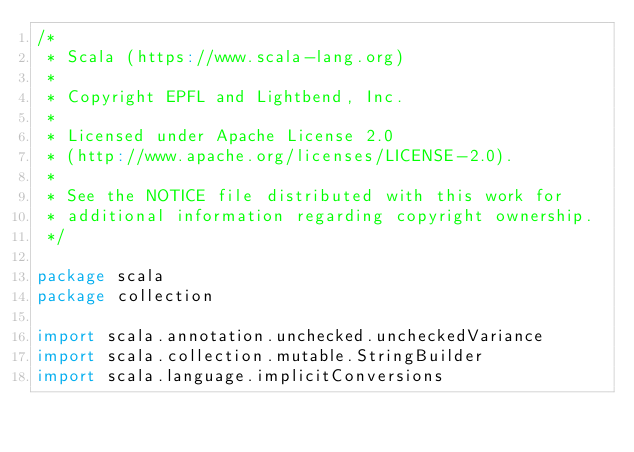<code> <loc_0><loc_0><loc_500><loc_500><_Scala_>/*
 * Scala (https://www.scala-lang.org)
 *
 * Copyright EPFL and Lightbend, Inc.
 *
 * Licensed under Apache License 2.0
 * (http://www.apache.org/licenses/LICENSE-2.0).
 *
 * See the NOTICE file distributed with this work for
 * additional information regarding copyright ownership.
 */

package scala
package collection

import scala.annotation.unchecked.uncheckedVariance
import scala.collection.mutable.StringBuilder
import scala.language.implicitConversions</code> 